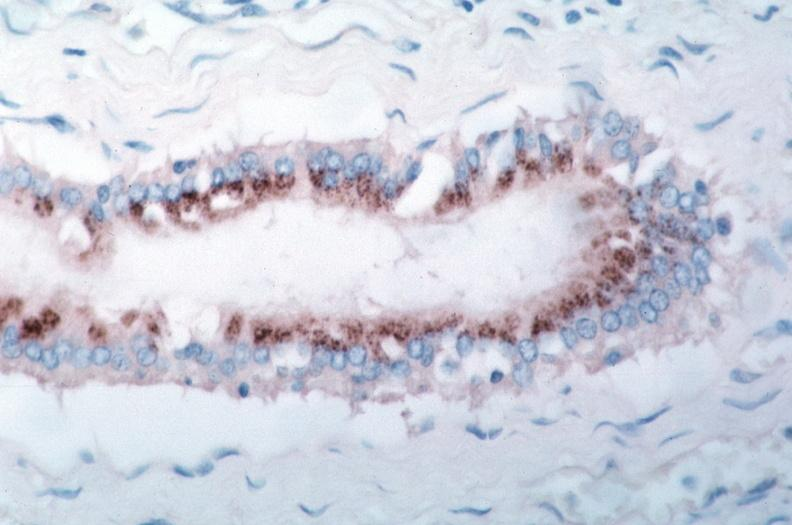what is present?
Answer the question using a single word or phrase. Vasculature 